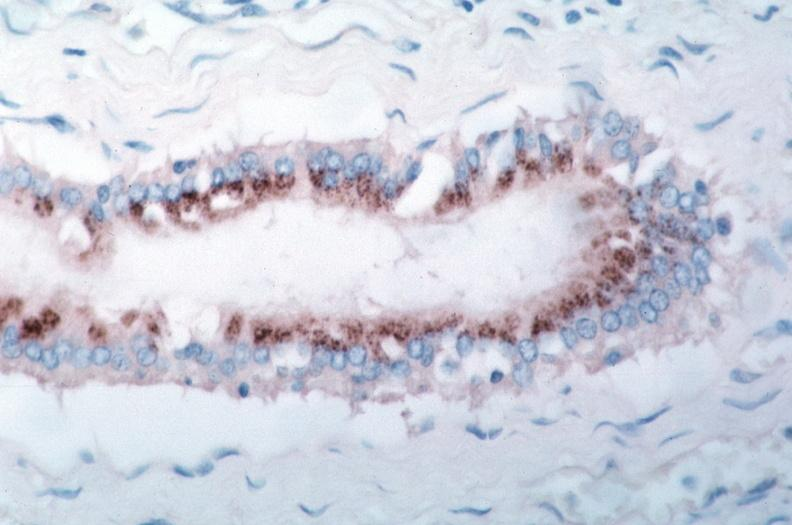what is present?
Answer the question using a single word or phrase. Vasculature 